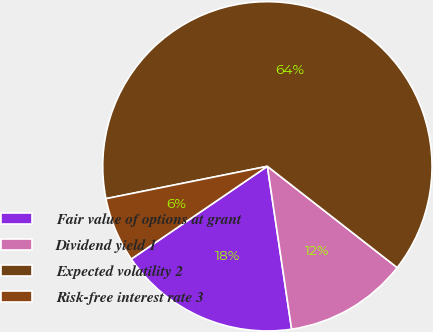Convert chart. <chart><loc_0><loc_0><loc_500><loc_500><pie_chart><fcel>Fair value of options at grant<fcel>Dividend yield 1<fcel>Expected volatility 2<fcel>Risk-free interest rate 3<nl><fcel>17.83%<fcel>12.1%<fcel>63.69%<fcel>6.37%<nl></chart> 